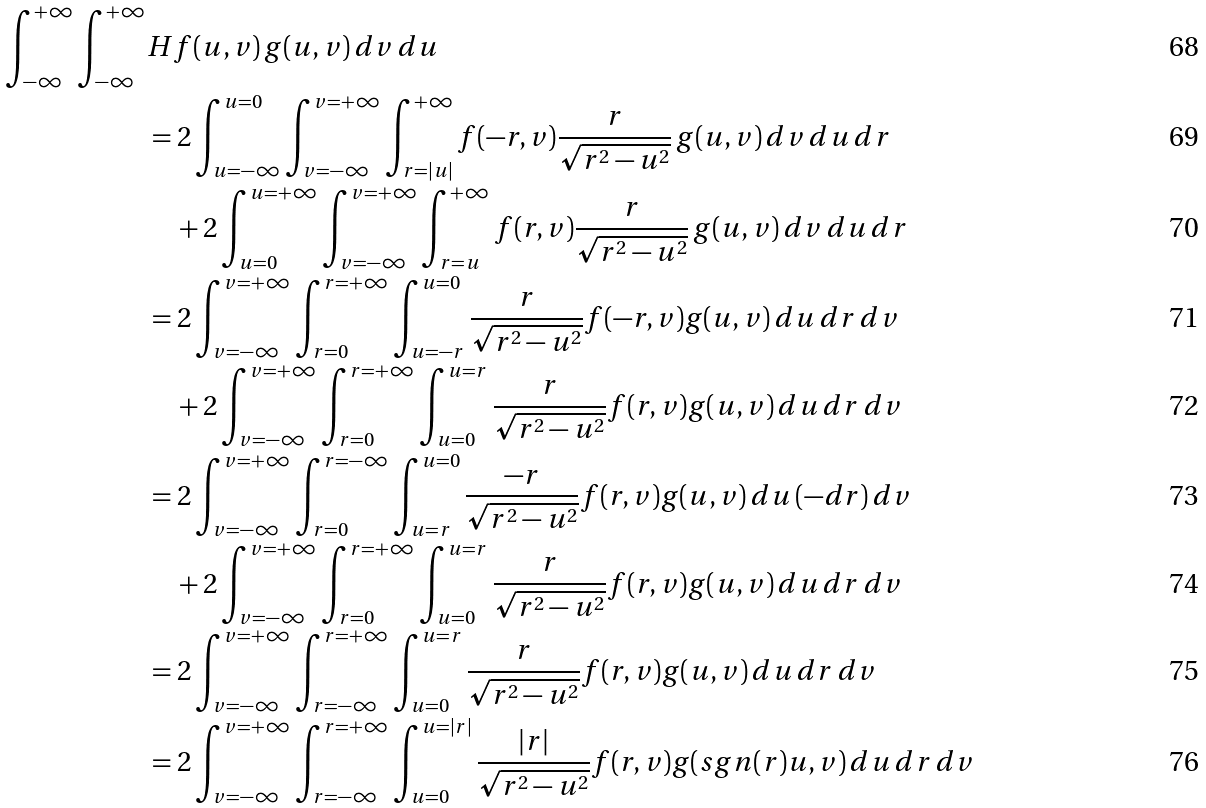Convert formula to latex. <formula><loc_0><loc_0><loc_500><loc_500>\int _ { - \infty } ^ { + \infty } \int _ { - \infty } ^ { + \infty } & H f ( u , v ) \, g ( u , v ) \, d v \, d u \\ & = 2 \int _ { u = - \infty } ^ { u = 0 } \int _ { v = - \infty } ^ { v = + \infty } \int _ { r = | u | } ^ { + \infty } f ( - r , v ) \frac { r } { \sqrt { r ^ { 2 } - u ^ { 2 } } } \, g ( u , v ) \, d v \, d u \, d r \\ & \quad + 2 \int _ { u = 0 } ^ { u = + \infty } \int _ { v = - \infty } ^ { v = + \infty } \int _ { r = u } ^ { + \infty } f ( r , v ) \frac { r } { \sqrt { r ^ { 2 } - u ^ { 2 } } } \, g ( u , v ) \, d v \, d u \, d r \\ & = 2 \int _ { v = - \infty } ^ { v = + \infty } \int _ { r = 0 } ^ { r = + \infty } \int _ { u = - r } ^ { u = 0 } \frac { r } { \sqrt { r ^ { 2 } - u ^ { 2 } } } f ( - r , v ) g ( u , v ) \, d u \, d r \, d v \\ & \quad + 2 \int _ { v = - \infty } ^ { v = + \infty } \int _ { r = 0 } ^ { r = + \infty } \int _ { u = 0 } ^ { u = r } \frac { r } { \sqrt { r ^ { 2 } - u ^ { 2 } } } f ( r , v ) g ( u , v ) \, d u \, d r \, d v \\ & = 2 \int _ { v = - \infty } ^ { v = + \infty } \int _ { r = 0 } ^ { r = - \infty } \int _ { u = r } ^ { u = 0 } \frac { - r } { \sqrt { r ^ { 2 } - u ^ { 2 } } } f ( r , v ) g ( u , v ) \, d u \, ( - d r ) \, d v \\ & \quad + 2 \int _ { v = - \infty } ^ { v = + \infty } \int _ { r = 0 } ^ { r = + \infty } \int _ { u = 0 } ^ { u = r } \frac { r } { \sqrt { r ^ { 2 } - u ^ { 2 } } } f ( r , v ) g ( u , v ) \, d u \, d r \, d v \\ & = 2 \int _ { v = - \infty } ^ { v = + \infty } \int _ { r = - \infty } ^ { r = + \infty } \int _ { u = 0 } ^ { u = r } \frac { r } { \sqrt { r ^ { 2 } - u ^ { 2 } } } f ( r , v ) g ( u , v ) \, d u \, d r \, d v \\ & = 2 \int _ { v = - \infty } ^ { v = + \infty } \int _ { r = - \infty } ^ { r = + \infty } \int _ { u = 0 } ^ { u = | r | } \frac { | r | } { \sqrt { r ^ { 2 } - u ^ { 2 } } } f ( r , v ) g ( s g n ( r ) u , v ) \, d u \, d r \, d v</formula> 